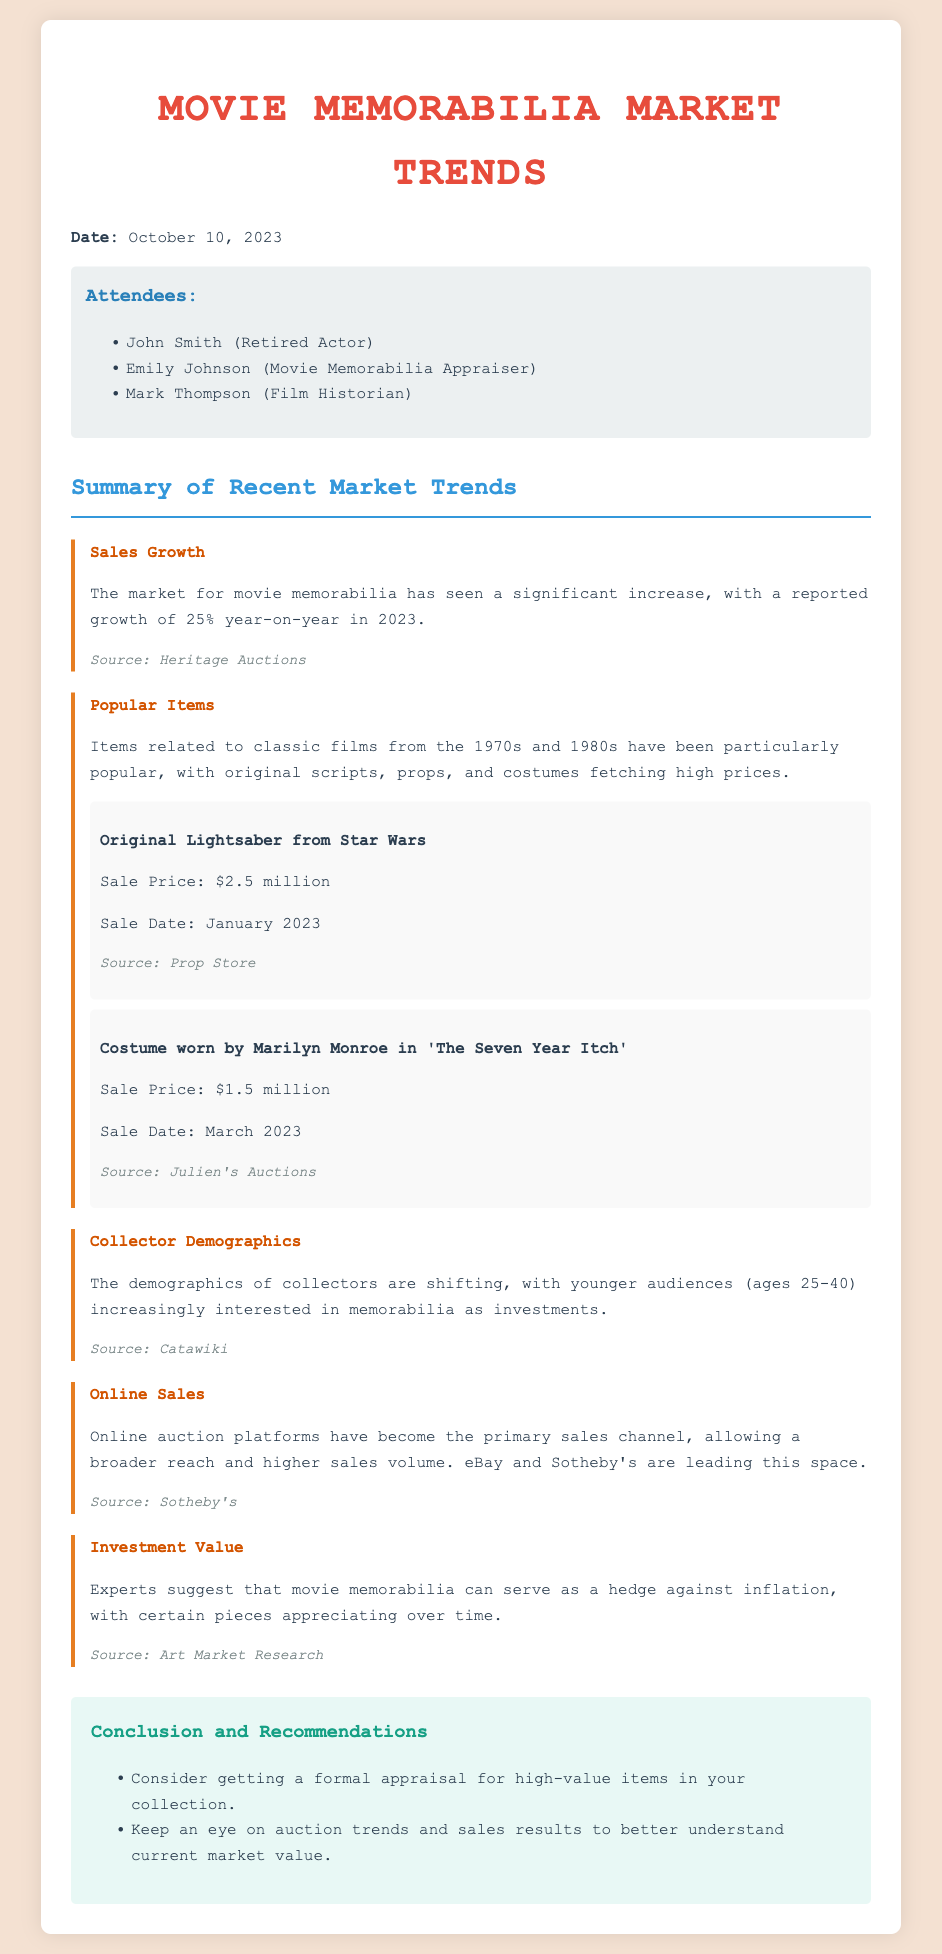What was the year-on-year sales growth percentage for movie memorabilia in 2023? The document states that the market for movie memorabilia has seen a significant increase, with a reported growth of 25% year-on-year in 2023.
Answer: 25% What are some popular items mentioned in the trends? The document lists items related to classic films from the 1970s and 1980s, specifically original scripts, props, and costumes.
Answer: Original scripts, props, and costumes What was the sale price of the original Lightsaber from Star Wars? The document provides the sale price for the Lightsaber, indicating that it fetched $2.5 million.
Answer: $2.5 million What is the primary sales channel for movie memorabilia? The document highlights that online auction platforms have become the primary sales channel.
Answer: Online auction platforms What age group is increasingly interested in memorabilia as investments? The demographics section of the document reveals that younger audiences aged 25-40 are more interested in memorabilia.
Answer: Ages 25-40 What conclusion is suggested regarding high-value items in your collection? The conclusion recommends considering a formal appraisal for high-value items.
Answer: Formal appraisal What percent growth did the movie memorabilia market achieve according to the document? The document mentions that the market saw a growth of 25% year-on-year in 2023.
Answer: 25% Which auction platforms are leading in online sales for movie memorabilia? The document mentions eBay and Sotheby's as the leading auction platforms in online sales.
Answer: eBay and Sotheby's 